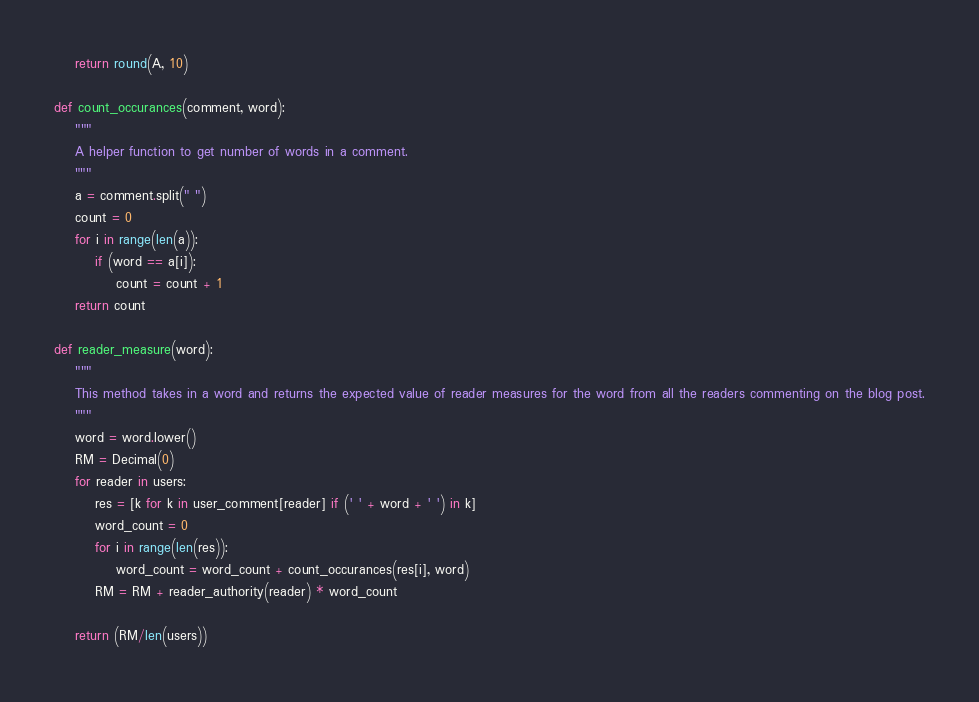<code> <loc_0><loc_0><loc_500><loc_500><_Python_>    return round(A, 10)

def count_occurances(comment, word):
    """
    A helper function to get number of words in a comment.
    """
    a = comment.split(" ")
    count = 0
    for i in range(len(a)):
        if (word == a[i]):
            count = count + 1
    return count

def reader_measure(word):
    """
    This method takes in a word and returns the expected value of reader measures for the word from all the readers commenting on the blog post.
    """
    word = word.lower()
    RM = Decimal(0)
    for reader in users:
        res = [k for k in user_comment[reader] if (' ' + word + ' ') in k]
        word_count = 0
        for i in range(len(res)):
            word_count = word_count + count_occurances(res[i], word)
        RM = RM + reader_authority(reader) * word_count
    
    return (RM/len(users))
</code> 